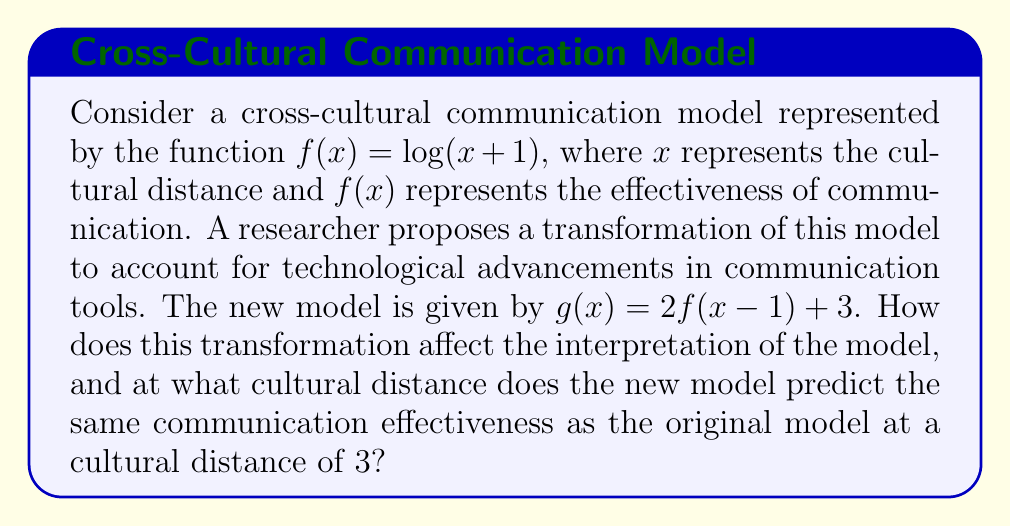Provide a solution to this math problem. To analyze this transformation, let's break it down step-by-step:

1) The original function is $f(x) = \log(x+1)$

2) The new function $g(x)$ is a transformation of $f(x)$ as follows:
   $g(x) = 2f(x-1) + 3$

3) Let's analyze each transformation:
   a) $(x-1)$ inside $f$ represents a horizontal shift 1 unit to the right
   b) Multiplying by 2 represents a vertical stretch by a factor of 2
   c) Adding 3 represents a vertical shift 3 units up

4) The new function can be written as:
   $g(x) = 2\log((x-1)+1) + 3 = 2\log(x) + 3$

5) Interpretation:
   - The horizontal shift means that the cultural distance is now measured from a new origin point, 1 unit to the right of the original.
   - The vertical stretch means that changes in cultural distance have a more pronounced effect on communication effectiveness.
   - The vertical shift represents an overall improvement in base communication effectiveness, possibly due to better technology.

6) To find where $g(x)$ equals $f(3)$:
   a) First, calculate $f(3)$:
      $f(3) = \log(3+1) = \log(4) = 1.386$ (approximately)

   b) Now, set up the equation:
      $2\log(x) + 3 = 1.386$

   c) Solve for $x$:
      $2\log(x) = -1.614$
      $\log(x) = -0.807$
      $x = 10^{-0.807} \approx 0.156$

Therefore, the new model predicts the same communication effectiveness at a cultural distance of approximately 0.156 as the original model did at a cultural distance of 3.
Answer: The transformation results in a model that is more sensitive to changes in cultural distance, with an overall increase in predicted communication effectiveness. The new model $g(x) = 2\log(x) + 3$ predicts the same communication effectiveness at a cultural distance of approximately 0.156 as the original model did at a cultural distance of 3. 